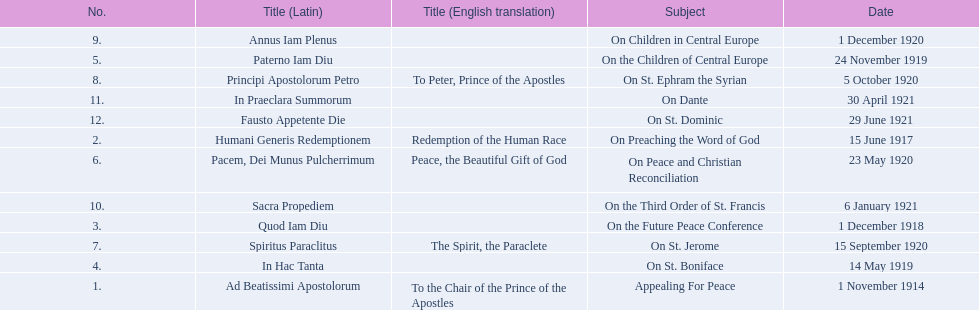What are all the subjects? Appealing For Peace, On Preaching the Word of God, On the Future Peace Conference, On St. Boniface, On the Children of Central Europe, On Peace and Christian Reconciliation, On St. Jerome, On St. Ephram the Syrian, On Children in Central Europe, On the Third Order of St. Francis, On Dante, On St. Dominic. What are their dates? 1 November 1914, 15 June 1917, 1 December 1918, 14 May 1919, 24 November 1919, 23 May 1920, 15 September 1920, 5 October 1920, 1 December 1920, 6 January 1921, 30 April 1921, 29 June 1921. Which subject's date belongs to 23 may 1920? On Peace and Christian Reconciliation. 